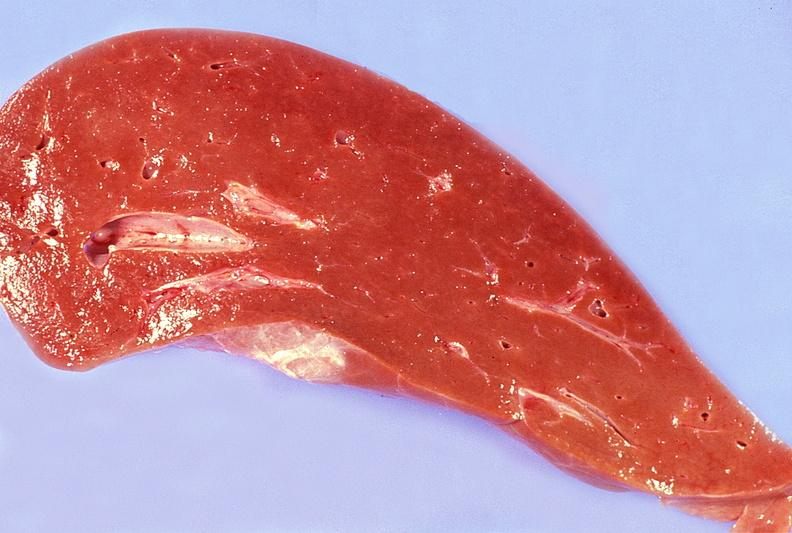what does this image show?
Answer the question using a single word or phrase. Normal liver 